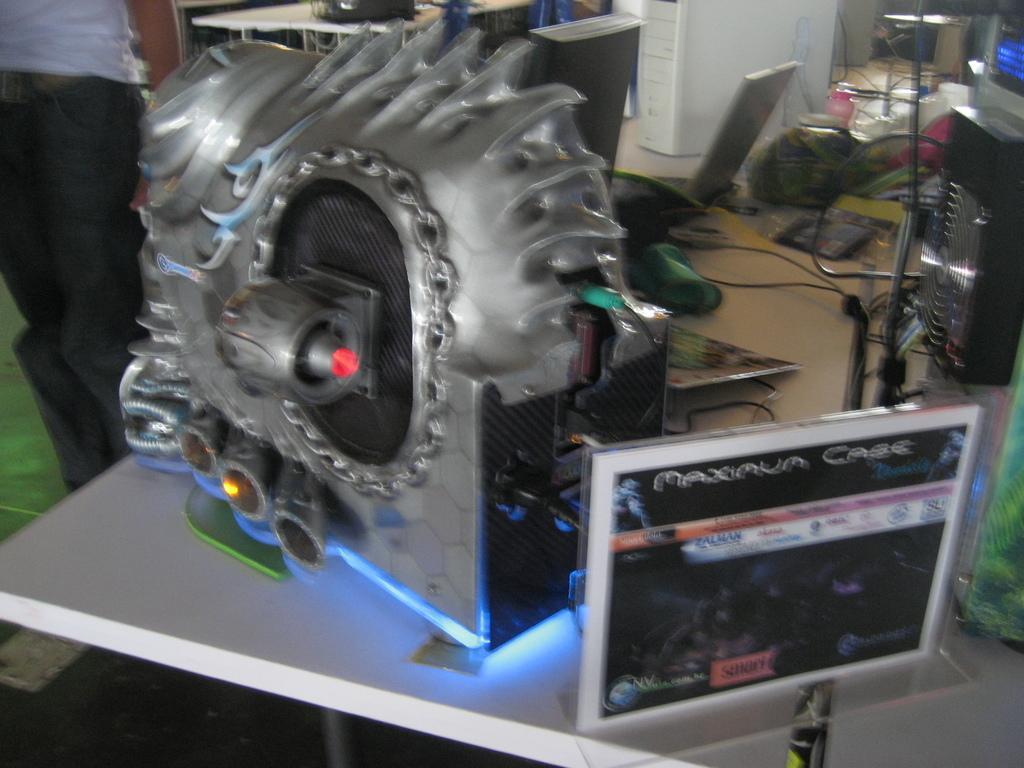How would you summarize this image in a sentence or two? In this image, we can see some tables with objects, devices and wires. We can see the ground and a person on the left. We can also see a poster with some images and text. 